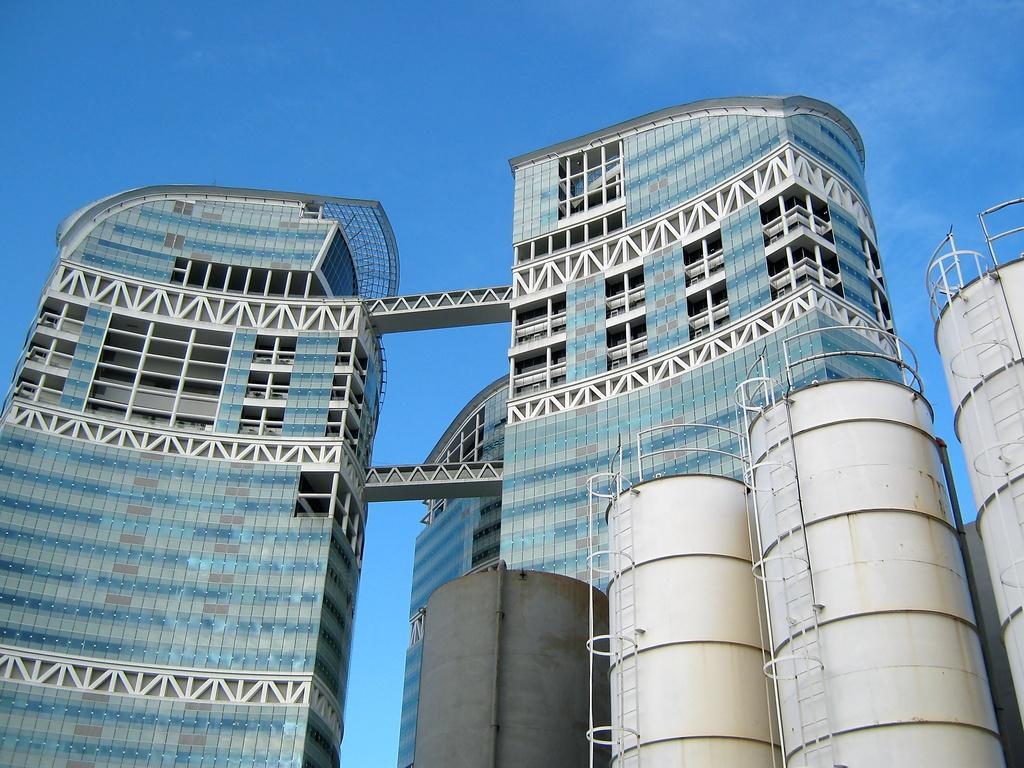Could you give a brief overview of what you see in this image? In this picture we can see the skyscraper. At the bottom left we can see the steel round barrels. At the top we can see the sky and clouds. 